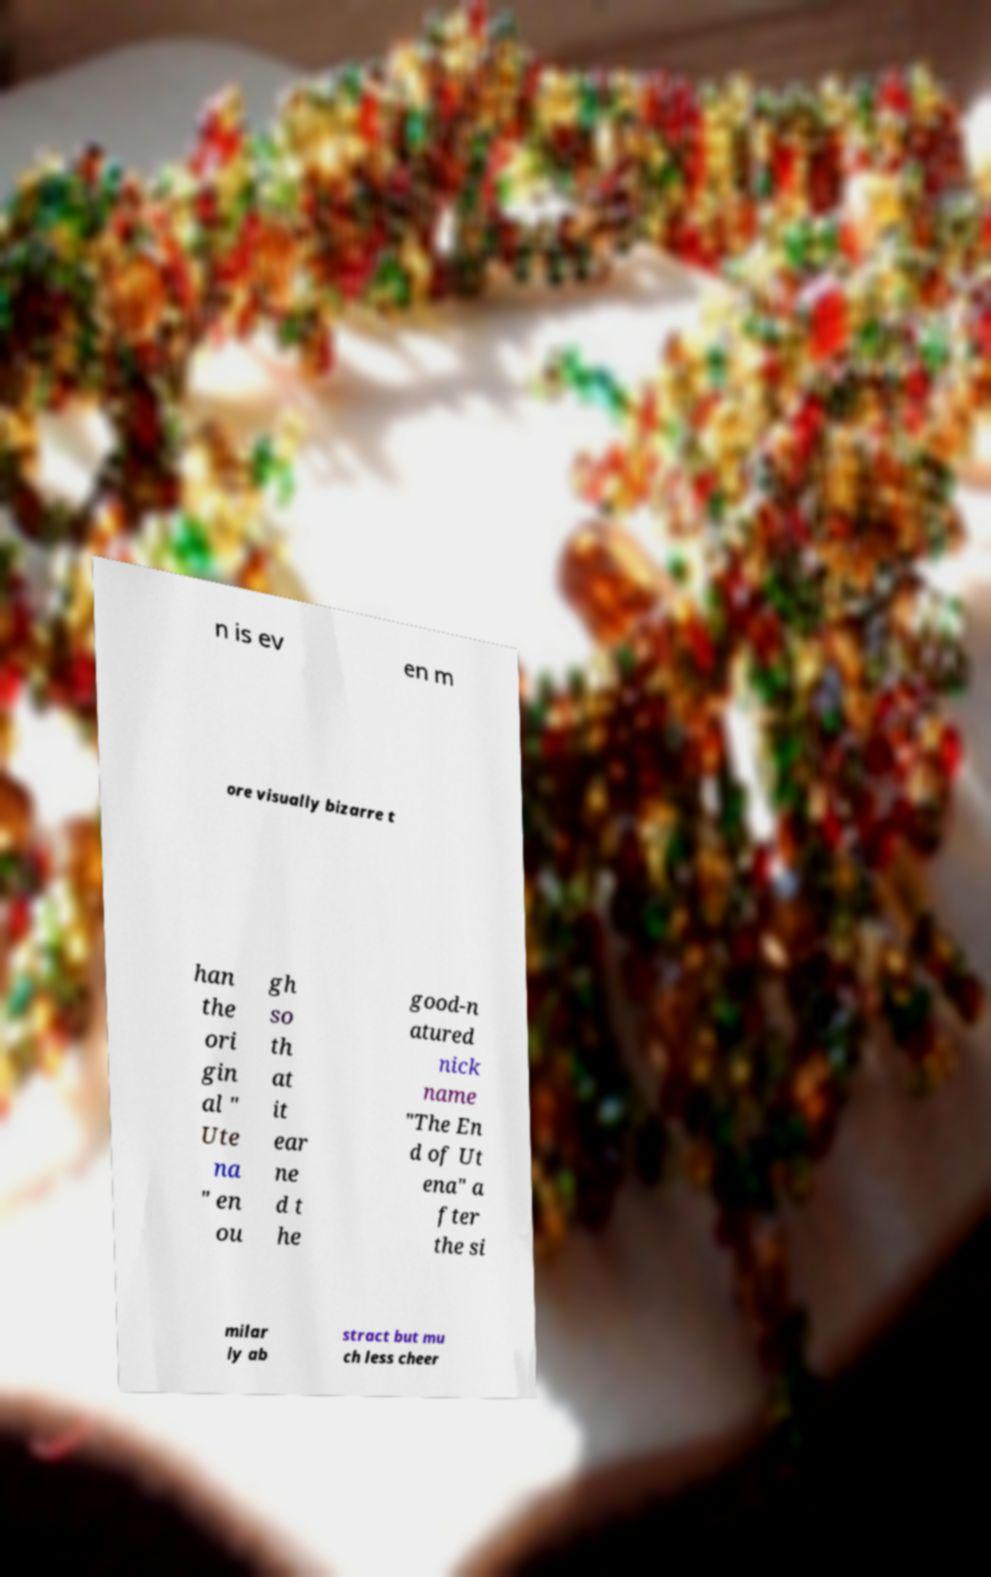Please identify and transcribe the text found in this image. n is ev en m ore visually bizarre t han the ori gin al " Ute na " en ou gh so th at it ear ne d t he good-n atured nick name "The En d of Ut ena" a fter the si milar ly ab stract but mu ch less cheer 